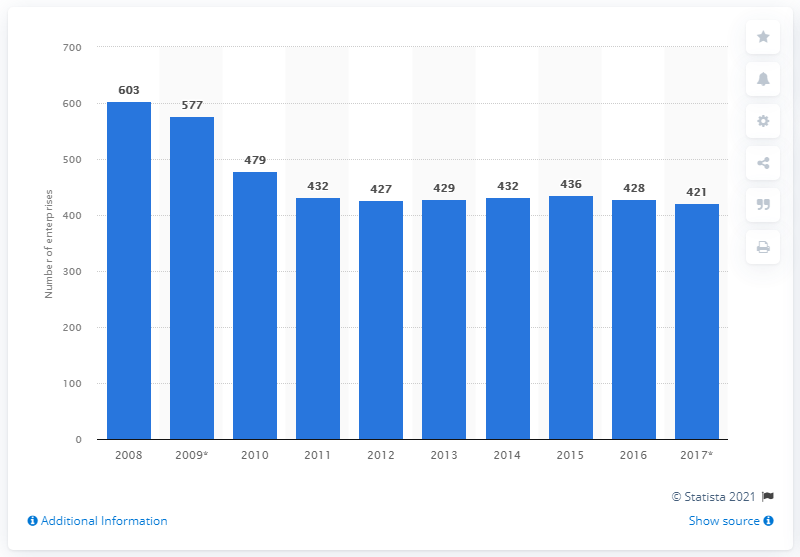Highlight a few significant elements in this photo. In 2016, there were 428 glass and glass products enterprises in Romania. 